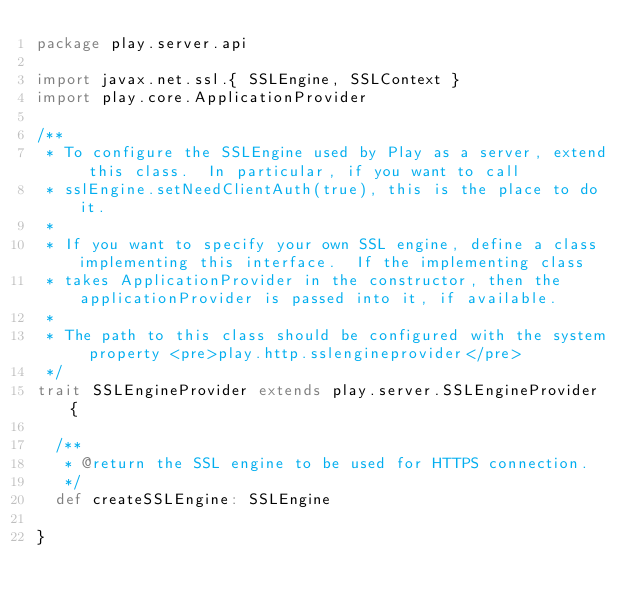<code> <loc_0><loc_0><loc_500><loc_500><_Scala_>package play.server.api

import javax.net.ssl.{ SSLEngine, SSLContext }
import play.core.ApplicationProvider

/**
 * To configure the SSLEngine used by Play as a server, extend this class.  In particular, if you want to call
 * sslEngine.setNeedClientAuth(true), this is the place to do it.
 *
 * If you want to specify your own SSL engine, define a class implementing this interface.  If the implementing class
 * takes ApplicationProvider in the constructor, then the applicationProvider is passed into it, if available.
 *
 * The path to this class should be configured with the system property <pre>play.http.sslengineprovider</pre>
 */
trait SSLEngineProvider extends play.server.SSLEngineProvider {

  /**
   * @return the SSL engine to be used for HTTPS connection.
   */
  def createSSLEngine: SSLEngine

}
</code> 